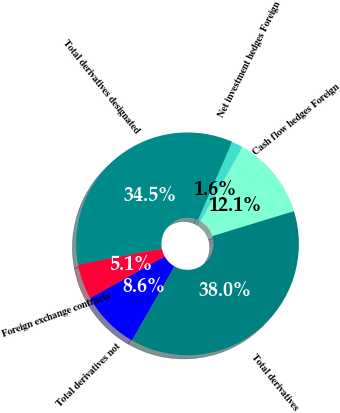Convert chart to OTSL. <chart><loc_0><loc_0><loc_500><loc_500><pie_chart><fcel>Cash flow hedges Foreign<fcel>Net investment hedges Foreign<fcel>Total derivatives designated<fcel>Foreign exchange contracts<fcel>Total derivatives not<fcel>Total derivatives<nl><fcel>12.07%<fcel>1.64%<fcel>34.54%<fcel>5.12%<fcel>8.6%<fcel>38.02%<nl></chart> 